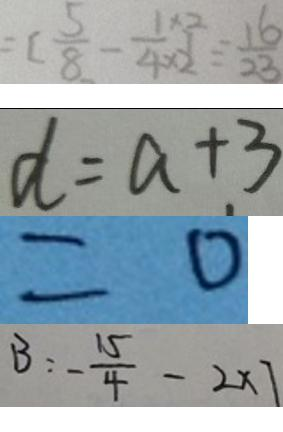<formula> <loc_0><loc_0><loc_500><loc_500>= [ \frac { 5 } { 8 } - \frac { 1 \times 2 } { 4 \times 2 } ] \div \frac { 1 6 } { 2 3 } 
 d = a + 3 
 = 0 
 B : - \frac { 1 5 } { 4 } - 2 \times 7</formula> 